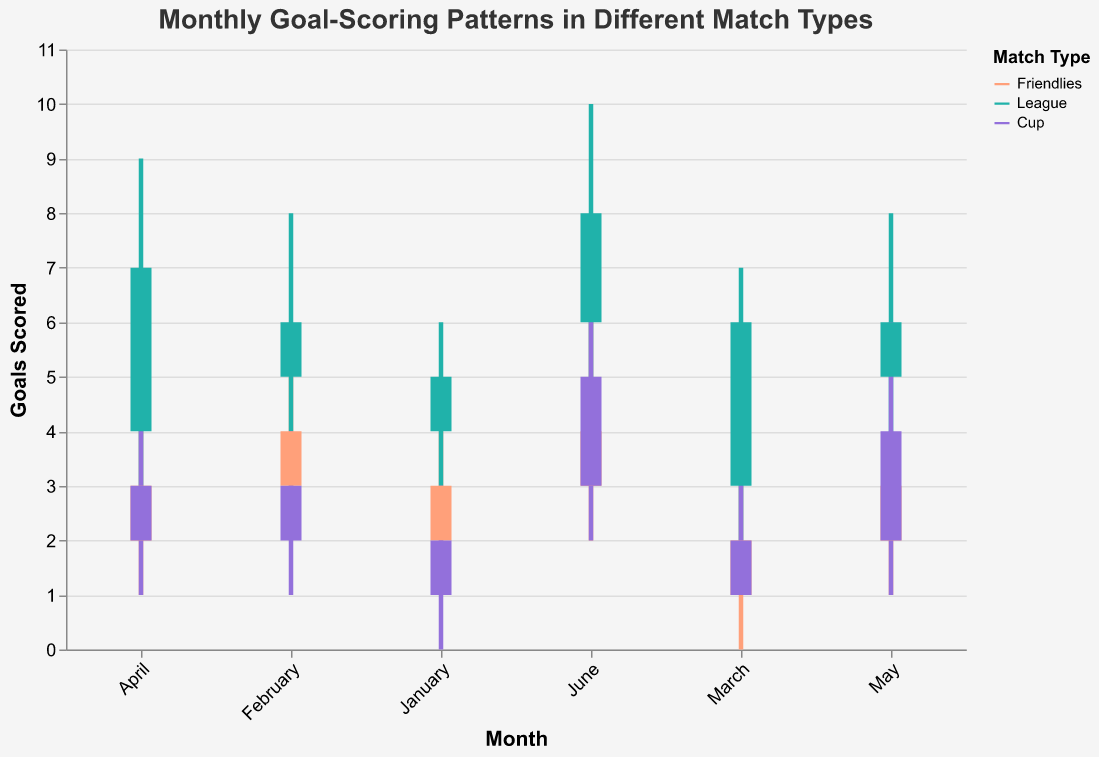Which month has the highest score in league matches? Observing the "High" score for each month in the league matches, April has the highest score with a value of 9.
Answer: April How does the goal-scoring pattern in January differ between friendlies and cup matches? In January, friendlies have an "Open" score of 2 and a "Close" score of 3, with a range from 1 to 4. Cup matches have an "Open" score of 1 and a "Close" score of 2, with a range from 0 to 3. Friendlies show higher goal-scoring than cup matches.
Answer: Friendlies have higher scores Which match type has the most stable goal range in April? Stability can be inferred from the shortest range between "Low" and "High" scores. In April, friendlies have a range from 1 to 5 (4 units), league matches from 2 to 9 (7 units), and cup matches from 1 to 5 (4 units). Both friendlies and cup matches have the same stability.
Answer: Friendlies and Cup What is the difference in "Close" scores for cup matches between February and June? For cup matches, the "Close" score in February is 3, and in June, it is 5. The difference is 5 - 3 = 2.
Answer: 2 Which match type shows the largest increase in "High" scores from May to June? Observing the "High" scores for May and June, friendlies increase from 4 to 6 (2 units), league matches from 8 to 10 (2 units), and cup matches from 6 to 7 (1 unit). Both friendlies and league matches have the largest increase.
Answer: Friendlies and League What is the average "Open" score for friendlies from January to June? The "Open" scores for friendlies are 2, 3, 1, 2, 2, 3. Sum these values to get 13, and then divide by 6 (13/6) to get approximately 2.17.
Answer: 2.17 Compare the total range of "High" scores between league and cup matches across all months. The total range involves summing the "High - Low" scores for each month. League matches: (6-3) + (8-4) + (7-2) + (9-2) + (8-3) + (10-4) = 24. Cup matches: (3-0) + (4-1) + (4-1) + (5-1) + (6-1) + (7-2) = 18. League matches have a larger total range.
Answer: League matches Which month shows the highest variability in goal scores for league matches? Variability can be seen from the largest difference between "Low" and "High" scores. For league matches: January (6-3 = 3), February (8-4 = 4), March (7-2 = 5), April (9-2 = 7), May (8-3 = 5), June (10-4 = 6). April shows the highest variability.
Answer: April 